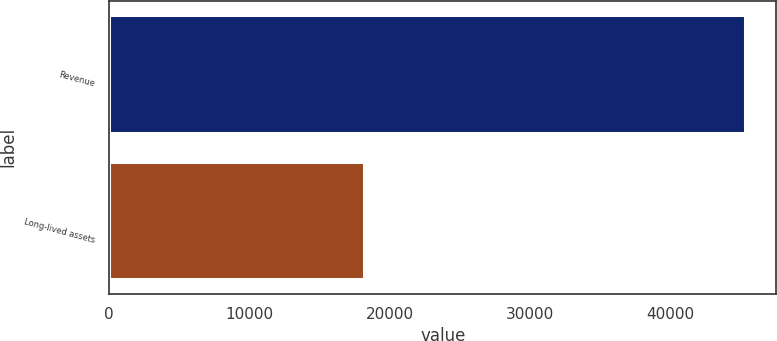<chart> <loc_0><loc_0><loc_500><loc_500><bar_chart><fcel>Revenue<fcel>Long-lived assets<nl><fcel>45309<fcel>18196<nl></chart> 